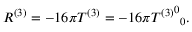Convert formula to latex. <formula><loc_0><loc_0><loc_500><loc_500>R ^ { ( 3 ) } = - 1 6 \pi T ^ { ( 3 ) } = - 1 6 \pi { { T ^ { ( 3 ) } } ^ { 0 } } _ { 0 } .</formula> 